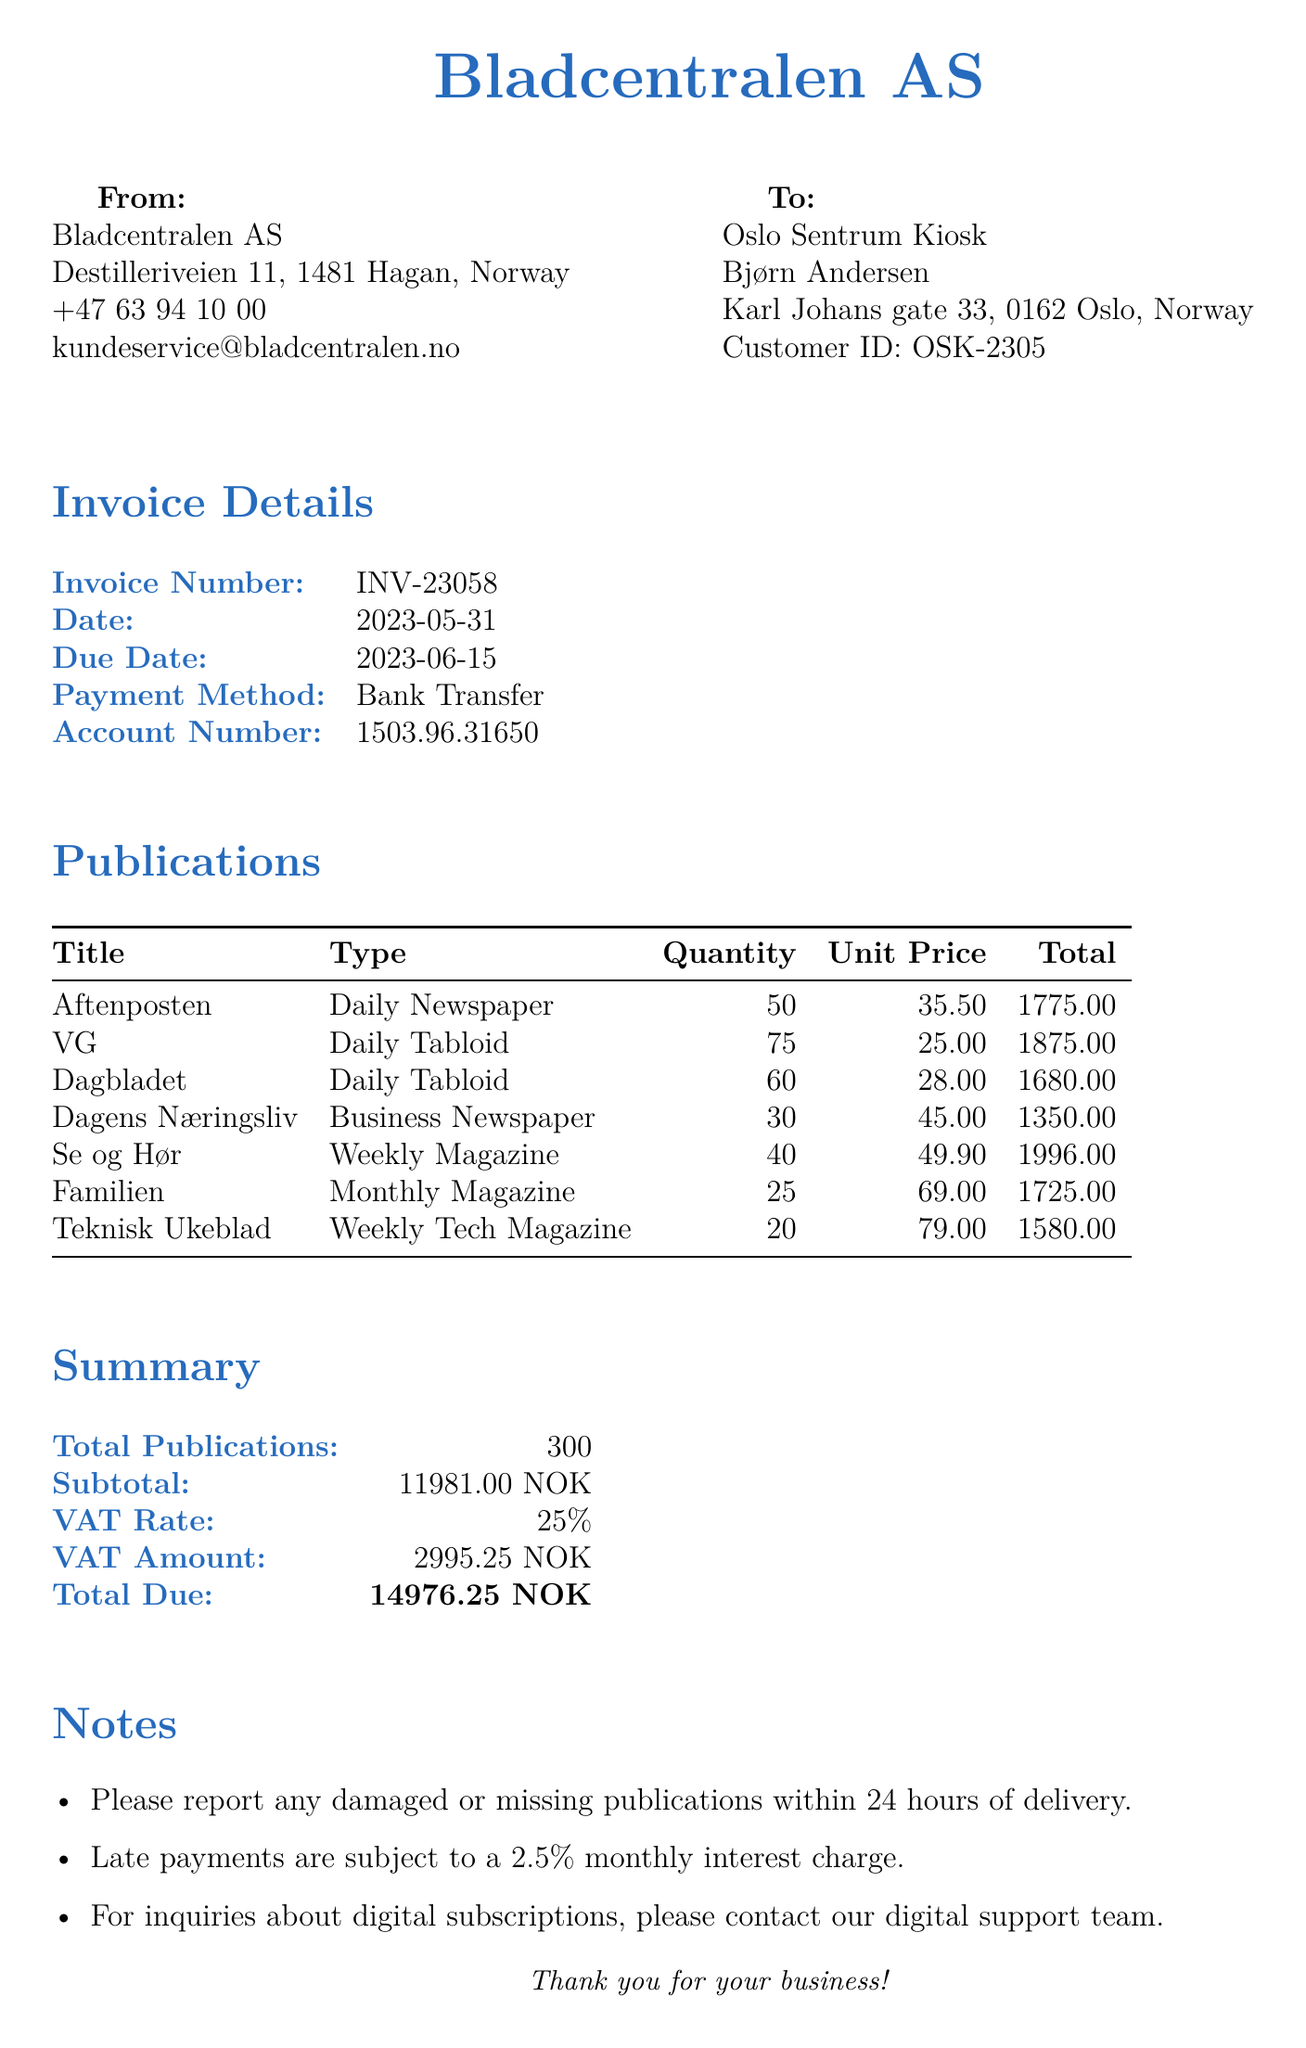What is the name of the distributor? The distributor's name is provided in the document as the sender of the invoice.
Answer: Bladcentralen AS What is the total amount due? The total amount due is calculated from the subtotal and VAT amount listed at the bottom of the document.
Answer: 14976.25 NOK How many copies of "Aftenposten" were delivered? The quantity of "Aftenposten" is specified in the publications section of the document.
Answer: 50 What is the VAT rate mentioned in the invoice? The VAT rate is explicitly mentioned in the summary section of the document.
Answer: 25% What is the due date of the invoice? The due date is listed in the invoice details section, indicating when payment must be made.
Answer: 2023-06-15 What is the unit price of "Se og Hør"? The unit price is provided in the specific publication details, essential for calculating total costs.
Answer: 49.90 Which payment method is specified for this invoice? The payment method is given in the invoice details section, clarifying how payment should be processed.
Answer: Bank Transfer What should be done if publications are damaged or missing? This is noted as a specific instruction under the notes section of the document.
Answer: Report within 24 hours How many total publications were ordered? The total publications figure is summarized at the end of the document to provide a quick overview.
Answer: 300 